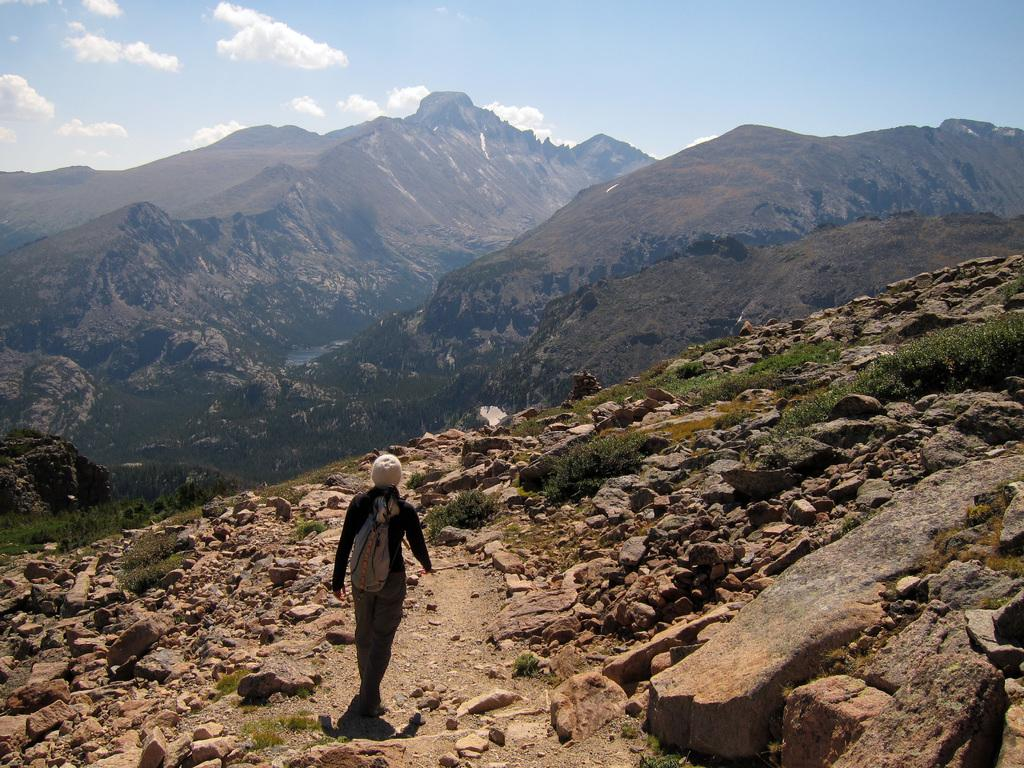What is the main subject of the image? There is a person walking in the image. Where is the person walking? The person is walking on a path on a hill. What can be seen around the person? There are rocks around the person. What is visible in the background of the image? Hills and the sky are visible in the background of the image. What is the condition of the sky in the image? The sky has clouds in it. What type of window can be seen in the image? There is no window present in the image. How many trains are visible in the image? There are no trains visible in the image. 